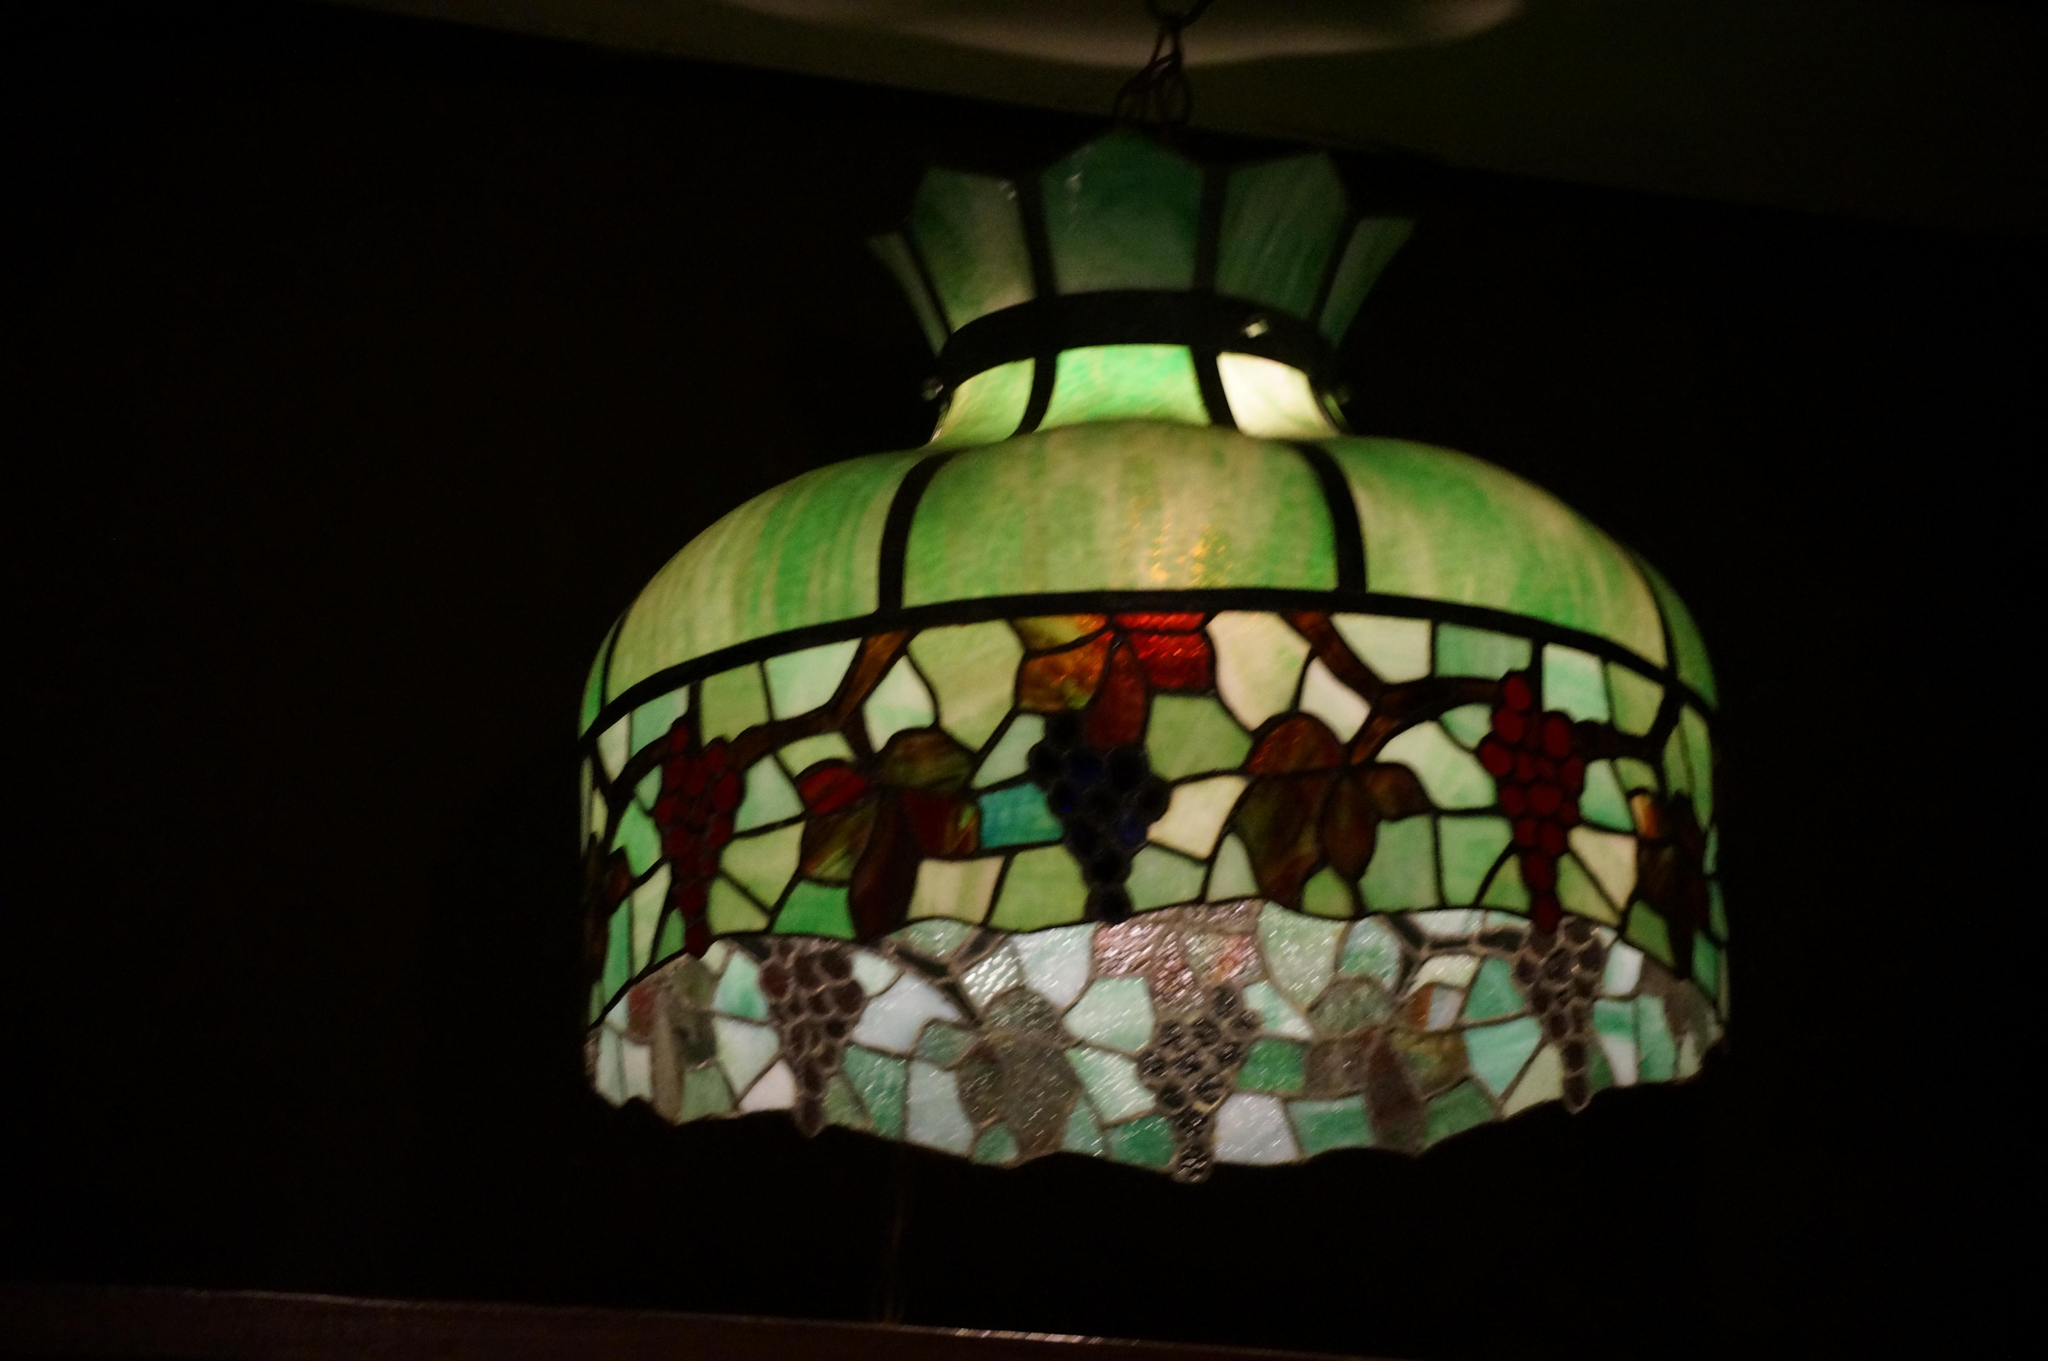What object is located in the middle of the image? There is a lamp in the middle of the image. What is the color of the background in the image? The background of the image is dark. What channel is the society watching in the image? There is no reference to a channel or society watching anything in the image; it only features a lamp in the middle of the dark background. 